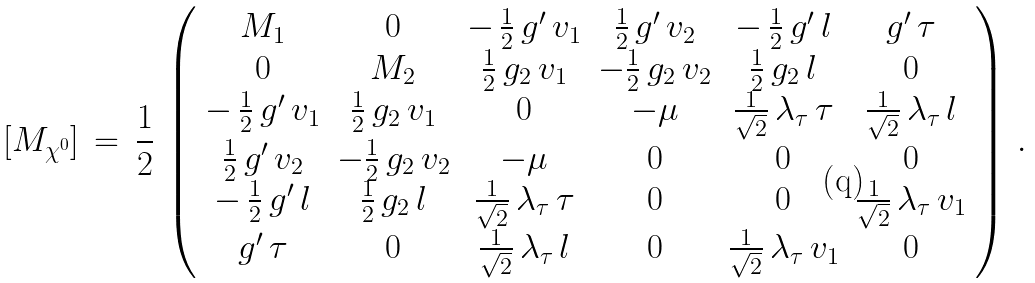<formula> <loc_0><loc_0><loc_500><loc_500>[ M _ { \chi ^ { 0 } } ] \, = \, \frac { 1 } { 2 } \, \left ( \begin{array} { c c c c c c } { { M _ { 1 } } } & { 0 } & { { - \, \frac { 1 } { 2 } \, g ^ { \prime } \, v _ { 1 } } } & { { \frac { 1 } { 2 } \, g ^ { \prime } \, v _ { 2 } } } & { { - \, \frac { 1 } { 2 } \, g ^ { \prime } \, l } } & { { g ^ { \prime } \, \tau } } \\ { 0 } & { { M _ { 2 } } } & { { \frac { 1 } { 2 } \, g _ { 2 } \, v _ { 1 } } } & { { - \frac { 1 } { 2 } \, g _ { 2 } \, v _ { 2 } } } & { { \frac { 1 } { 2 } \, g _ { 2 } \, l } } & { 0 } \\ { { - \, \frac { 1 } { 2 } \, g ^ { \prime } \, v _ { 1 } } } & { { \frac { 1 } { 2 } \, g _ { 2 } \, v _ { 1 } } } & { 0 } & { - \mu } & { { \frac { 1 } { \sqrt { 2 } } \, \lambda _ { \tau } \, \tau } } & { { \frac { 1 } { \sqrt { 2 } } \, \lambda _ { \tau } \, l } } \\ { { \frac { 1 } { 2 } \, g ^ { \prime } \, v _ { 2 } } } & { { - \frac { 1 } { 2 } \, g _ { 2 } \, v _ { 2 } } } & { - \mu } & { 0 } & { 0 } & { 0 } \\ { { - \, \frac { 1 } { 2 } \, g ^ { \prime } \, l } } & { { \frac { 1 } { 2 } \, g _ { 2 } \, l } } & { { \frac { 1 } { \sqrt { 2 } } \, \lambda _ { \tau } \, \tau } } & { 0 } & { 0 } & { { \frac { 1 } { \sqrt { 2 } } \, \lambda _ { \tau } \, v _ { 1 } } } \\ { { g ^ { \prime } \, \tau } } & { 0 } & { { \frac { 1 } { \sqrt { 2 } } \, \lambda _ { \tau } \, l } } & { 0 } & { { \frac { 1 } { \sqrt { 2 } } \, \lambda _ { \tau } \, v _ { 1 } } } & { 0 } \end{array} \right ) \, .</formula> 